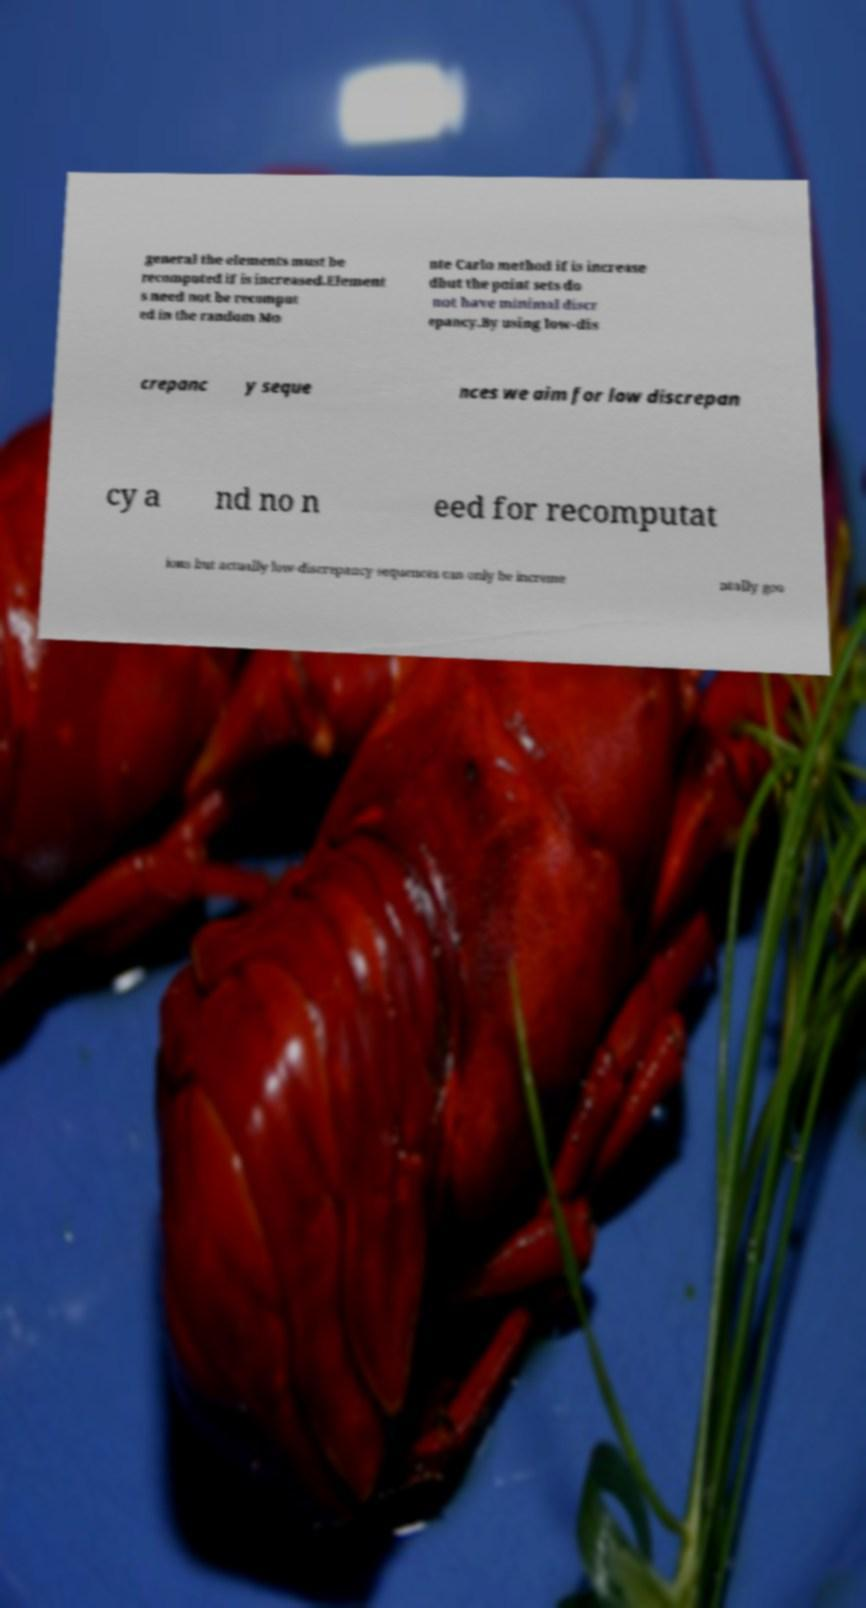Could you assist in decoding the text presented in this image and type it out clearly? general the elements must be recomputed if is increased.Element s need not be recomput ed in the random Mo nte Carlo method if is increase dbut the point sets do not have minimal discr epancy.By using low-dis crepanc y seque nces we aim for low discrepan cy a nd no n eed for recomputat ions but actually low-discrepancy sequences can only be increme ntally goo 